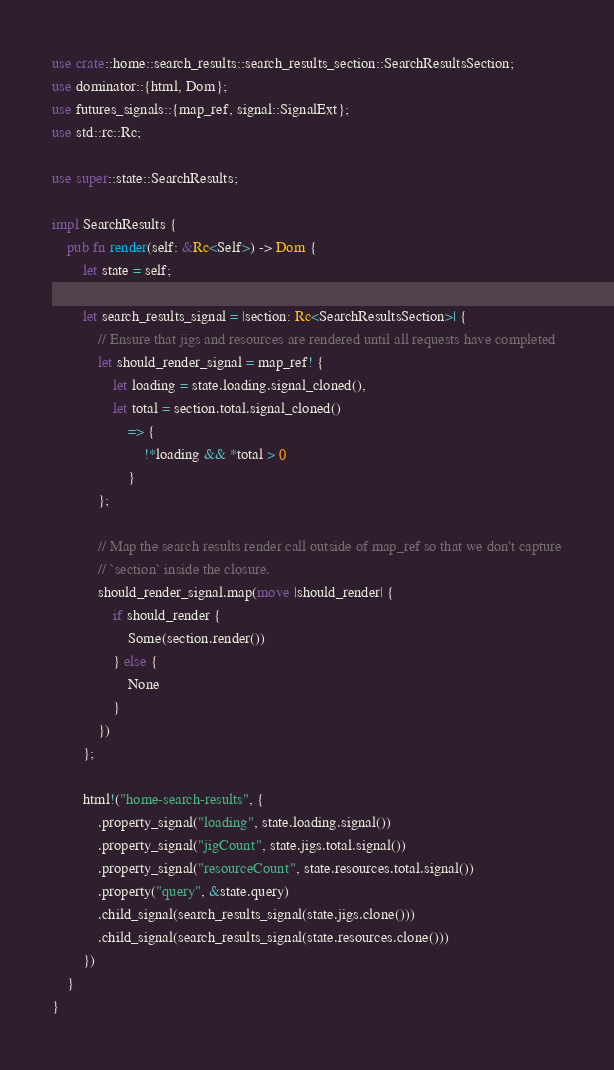<code> <loc_0><loc_0><loc_500><loc_500><_Rust_>use crate::home::search_results::search_results_section::SearchResultsSection;
use dominator::{html, Dom};
use futures_signals::{map_ref, signal::SignalExt};
use std::rc::Rc;

use super::state::SearchResults;

impl SearchResults {
    pub fn render(self: &Rc<Self>) -> Dom {
        let state = self;

        let search_results_signal = |section: Rc<SearchResultsSection>| {
            // Ensure that jigs and resources are rendered until all requests have completed
            let should_render_signal = map_ref! {
                let loading = state.loading.signal_cloned(),
                let total = section.total.signal_cloned()
                    => {
                        !*loading && *total > 0
                    }
            };

            // Map the search results render call outside of map_ref so that we don't capture
            // `section` inside the closure.
            should_render_signal.map(move |should_render| {
                if should_render {
                    Some(section.render())
                } else {
                    None
                }
            })
        };

        html!("home-search-results", {
            .property_signal("loading", state.loading.signal())
            .property_signal("jigCount", state.jigs.total.signal())
            .property_signal("resourceCount", state.resources.total.signal())
            .property("query", &state.query)
            .child_signal(search_results_signal(state.jigs.clone()))
            .child_signal(search_results_signal(state.resources.clone()))
        })
    }
}
</code> 